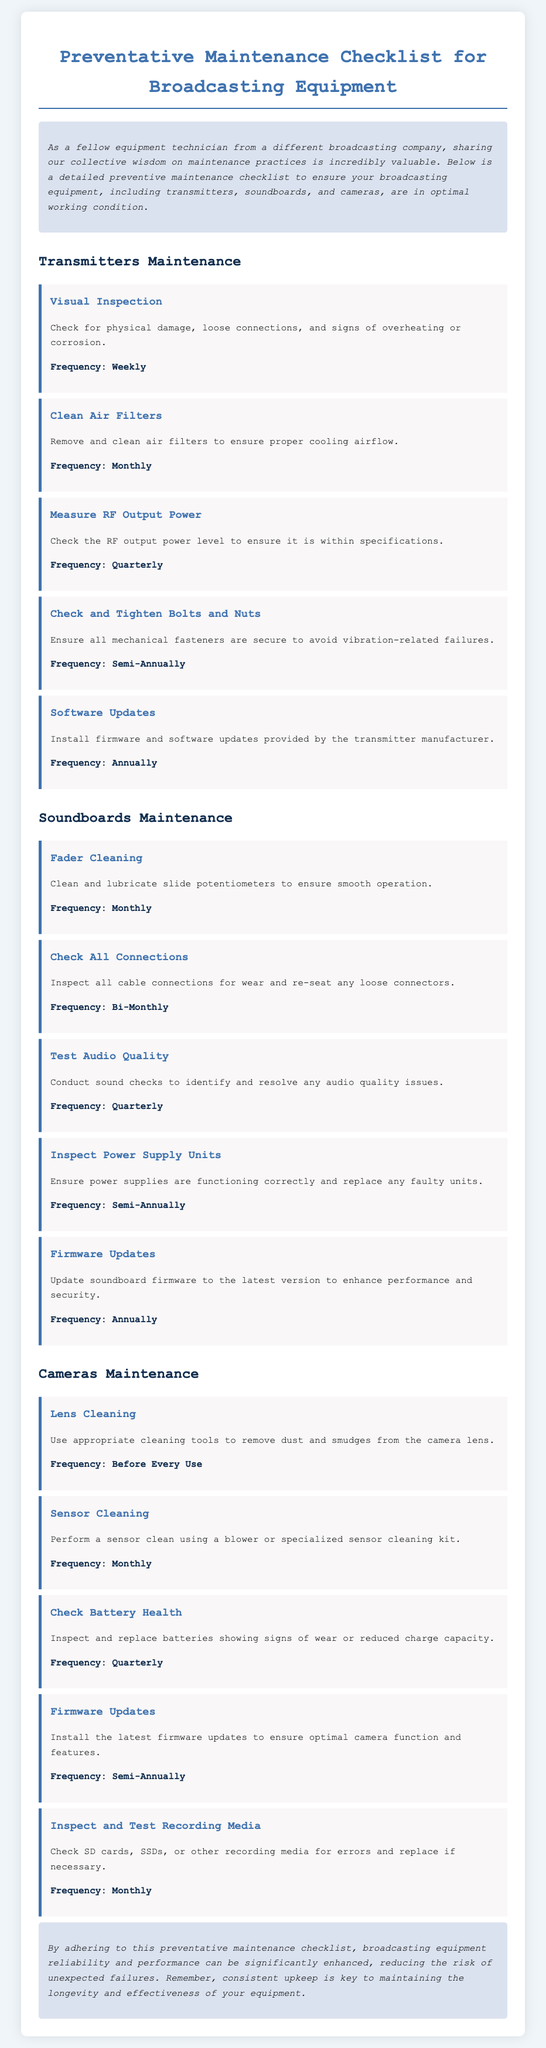What is the frequency for cleaning air filters? The frequency for cleaning air filters is specified in the maintenance tasks for transmitters.
Answer: Monthly What should be checked and tightened semi-annually? This information pertains to mechanical fasteners within the transmitters.
Answer: Bolts and Nuts How often should lens cleaning be performed? The document mentions the frequency of lens cleaning for cameras.
Answer: Before Every Use What maintenance task should be conducted for sound quality? This task relates to ensuring soundboards function properly by identifying quality issues.
Answer: Test Audio Quality What action should be taken if a battery shows signs of wear? The document specifies actions regarding battery health during maintenance.
Answer: Replace What is the main benefit of following the preventative maintenance checklist? This question pertains to the overall intention behind the maintenance practices outlined in the document.
Answer: Reliability and performance What should be performed quarterly for transmitters? The maintenance schedule includes several tasks for transmitters that should occur quarterly.
Answer: Measure RF Output Power How often is firmware updated for cameras? The document indicates the recommended frequency for firmware updates specific to cameras.
Answer: Semi-Annually 